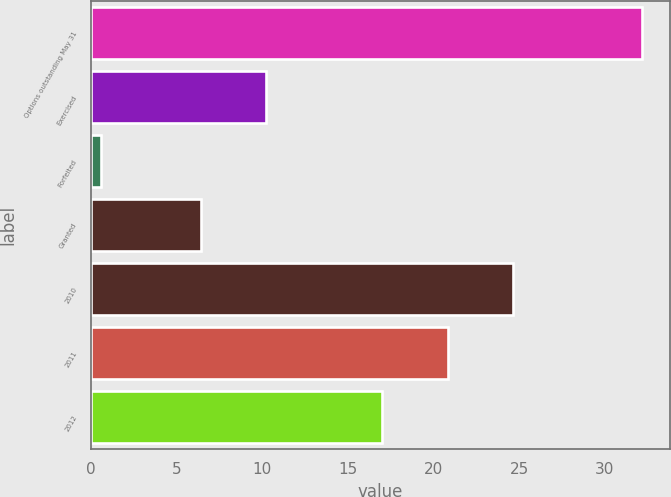Convert chart to OTSL. <chart><loc_0><loc_0><loc_500><loc_500><bar_chart><fcel>Options outstanding May 31<fcel>Exercised<fcel>Forfeited<fcel>Granted<fcel>2010<fcel>2011<fcel>2012<nl><fcel>32.2<fcel>10.22<fcel>0.6<fcel>6.4<fcel>24.64<fcel>20.82<fcel>17<nl></chart> 